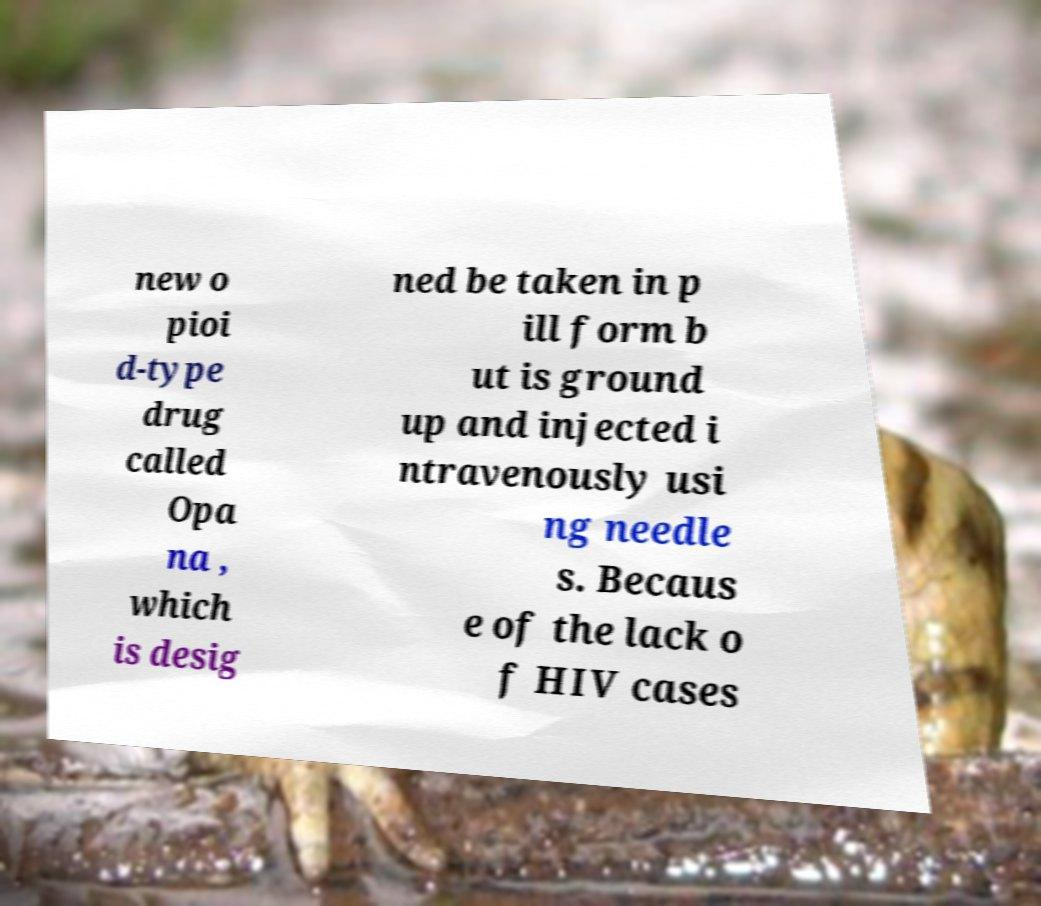There's text embedded in this image that I need extracted. Can you transcribe it verbatim? new o pioi d-type drug called Opa na , which is desig ned be taken in p ill form b ut is ground up and injected i ntravenously usi ng needle s. Becaus e of the lack o f HIV cases 